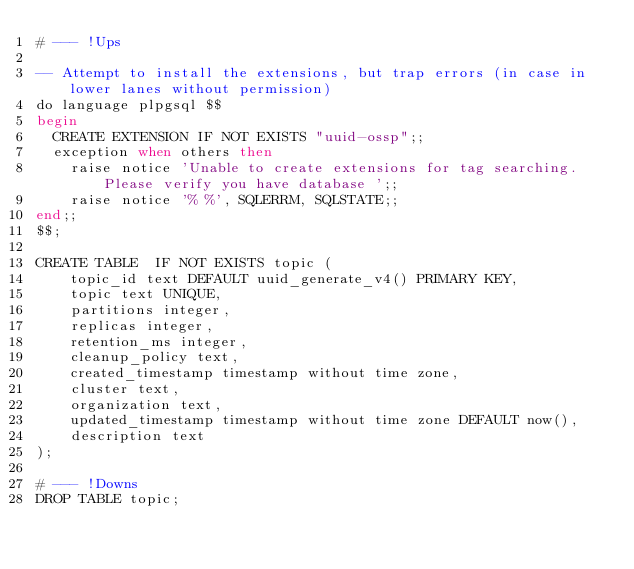Convert code to text. <code><loc_0><loc_0><loc_500><loc_500><_SQL_># --- !Ups

-- Attempt to install the extensions, but trap errors (in case in lower lanes without permission)
do language plpgsql $$
begin
  CREATE EXTENSION IF NOT EXISTS "uuid-ossp";;
  exception when others then
    raise notice 'Unable to create extensions for tag searching. Please verify you have database ';;
    raise notice '% %', SQLERRM, SQLSTATE;;
end;;
$$;

CREATE TABLE  IF NOT EXISTS topic (
    topic_id text DEFAULT uuid_generate_v4() PRIMARY KEY,
    topic text UNIQUE,
    partitions integer,
    replicas integer,
    retention_ms integer,
    cleanup_policy text,
    created_timestamp timestamp without time zone,
    cluster text,
    organization text,
    updated_timestamp timestamp without time zone DEFAULT now(),
    description text
);

# --- !Downs
DROP TABLE topic;
</code> 